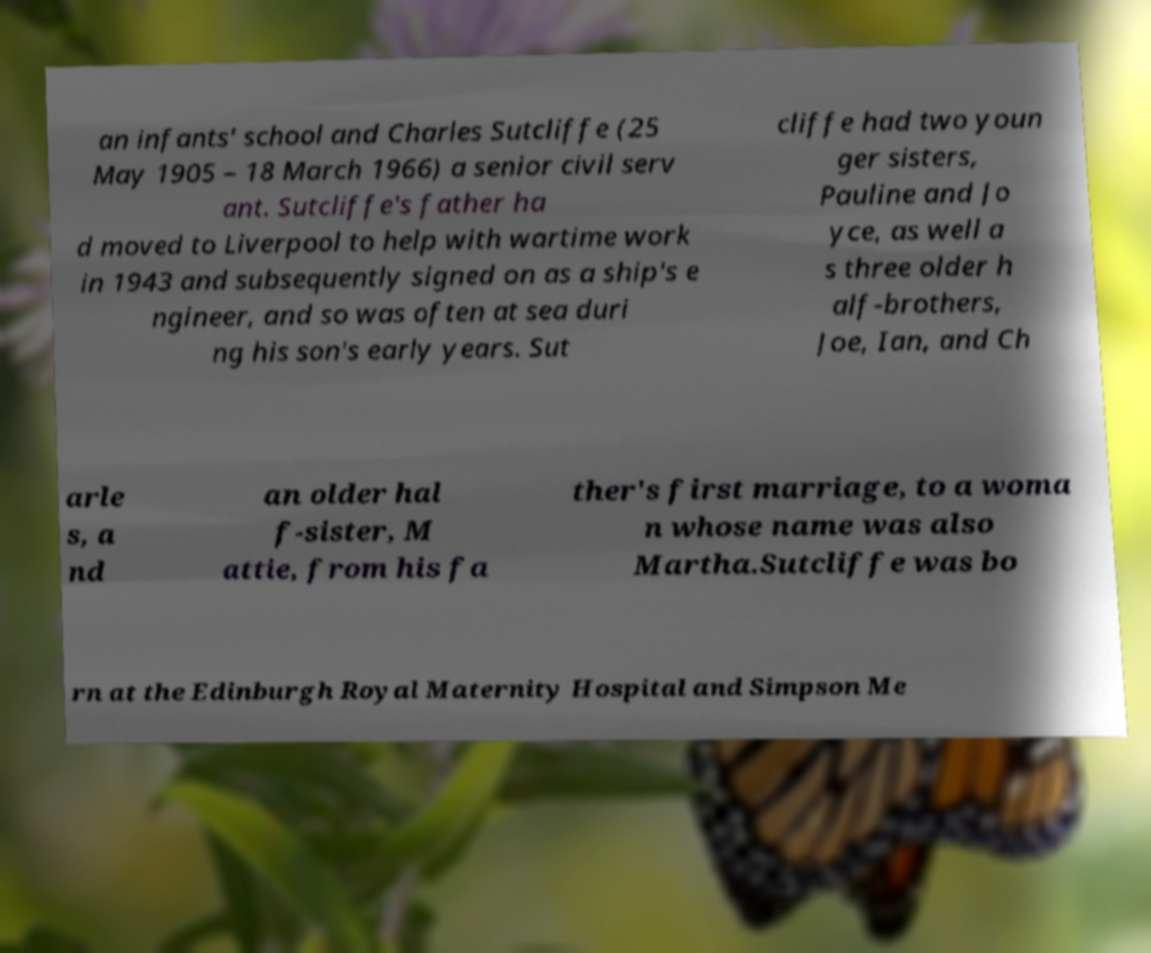Can you read and provide the text displayed in the image?This photo seems to have some interesting text. Can you extract and type it out for me? an infants' school and Charles Sutcliffe (25 May 1905 – 18 March 1966) a senior civil serv ant. Sutcliffe's father ha d moved to Liverpool to help with wartime work in 1943 and subsequently signed on as a ship's e ngineer, and so was often at sea duri ng his son's early years. Sut cliffe had two youn ger sisters, Pauline and Jo yce, as well a s three older h alf-brothers, Joe, Ian, and Ch arle s, a nd an older hal f-sister, M attie, from his fa ther's first marriage, to a woma n whose name was also Martha.Sutcliffe was bo rn at the Edinburgh Royal Maternity Hospital and Simpson Me 